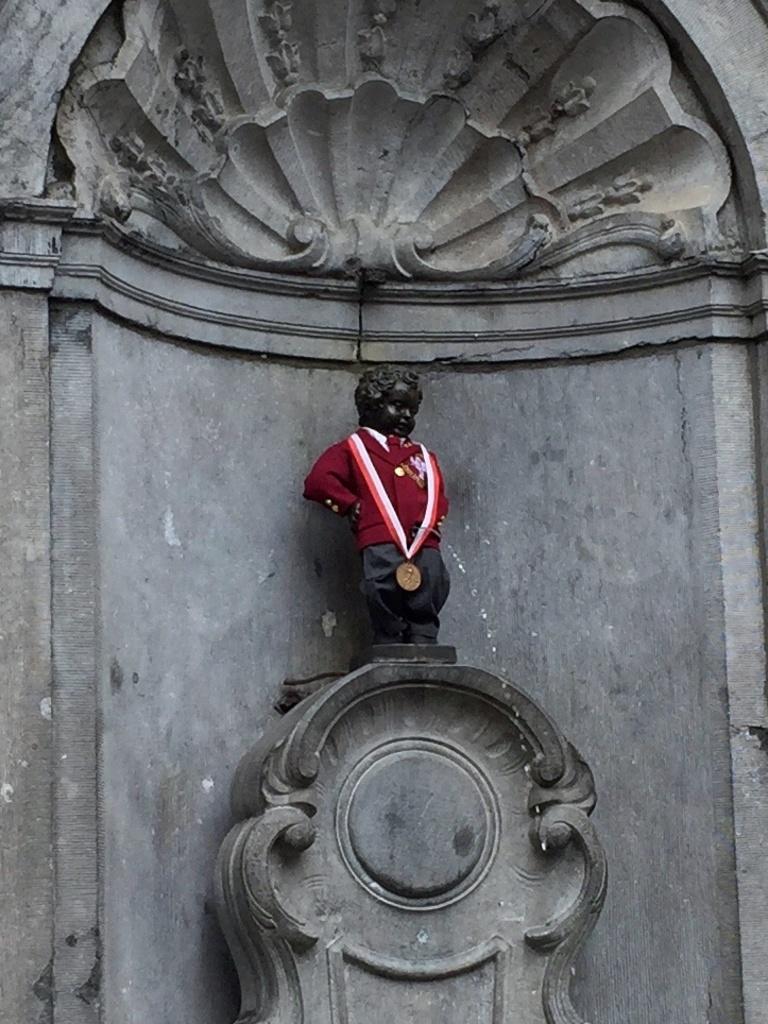In one or two sentences, can you explain what this image depicts? In this image I can see a statue which is black in color and wearing red and black colored dress. I can see a rock sculpture which is ash in color. 